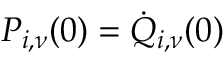Convert formula to latex. <formula><loc_0><loc_0><loc_500><loc_500>P _ { i , \nu } ( 0 ) = \dot { Q } _ { i , \nu } ( 0 )</formula> 